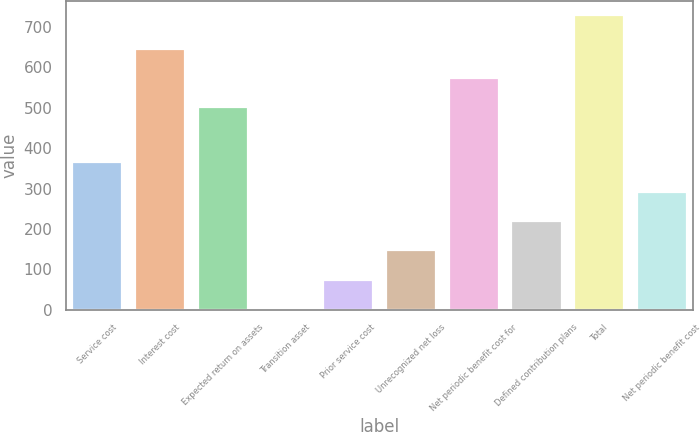Convert chart to OTSL. <chart><loc_0><loc_0><loc_500><loc_500><bar_chart><fcel>Service cost<fcel>Interest cost<fcel>Expected return on assets<fcel>Transition asset<fcel>Prior service cost<fcel>Unrecognized net loss<fcel>Net periodic benefit cost for<fcel>Defined contribution plans<fcel>Total<fcel>Net periodic benefit cost<nl><fcel>365<fcel>646.6<fcel>501<fcel>1<fcel>73.8<fcel>146.6<fcel>573.8<fcel>219.4<fcel>729<fcel>292.2<nl></chart> 